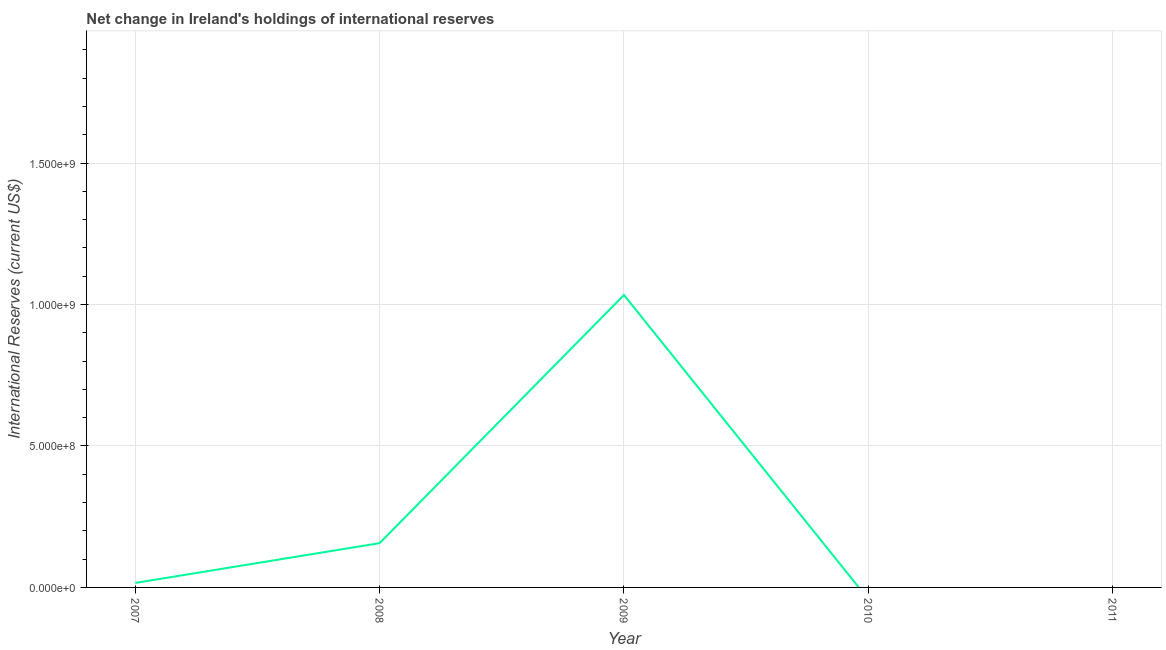What is the reserves and related items in 2011?
Make the answer very short. 0. Across all years, what is the maximum reserves and related items?
Keep it short and to the point. 1.03e+09. What is the sum of the reserves and related items?
Your answer should be very brief. 1.21e+09. What is the difference between the reserves and related items in 2008 and 2009?
Offer a very short reply. -8.77e+08. What is the average reserves and related items per year?
Your response must be concise. 2.41e+08. What is the median reserves and related items?
Provide a succinct answer. 1.60e+07. What is the difference between the highest and the second highest reserves and related items?
Offer a terse response. 8.77e+08. Is the sum of the reserves and related items in 2008 and 2009 greater than the maximum reserves and related items across all years?
Keep it short and to the point. Yes. What is the difference between the highest and the lowest reserves and related items?
Your response must be concise. 1.03e+09. Does the reserves and related items monotonically increase over the years?
Provide a short and direct response. No. How many years are there in the graph?
Ensure brevity in your answer.  5. What is the difference between two consecutive major ticks on the Y-axis?
Provide a succinct answer. 5.00e+08. Does the graph contain any zero values?
Your response must be concise. Yes. What is the title of the graph?
Offer a very short reply. Net change in Ireland's holdings of international reserves. What is the label or title of the X-axis?
Give a very brief answer. Year. What is the label or title of the Y-axis?
Keep it short and to the point. International Reserves (current US$). What is the International Reserves (current US$) in 2007?
Offer a terse response. 1.60e+07. What is the International Reserves (current US$) in 2008?
Provide a short and direct response. 1.57e+08. What is the International Reserves (current US$) of 2009?
Provide a succinct answer. 1.03e+09. What is the difference between the International Reserves (current US$) in 2007 and 2008?
Ensure brevity in your answer.  -1.41e+08. What is the difference between the International Reserves (current US$) in 2007 and 2009?
Ensure brevity in your answer.  -1.02e+09. What is the difference between the International Reserves (current US$) in 2008 and 2009?
Provide a short and direct response. -8.77e+08. What is the ratio of the International Reserves (current US$) in 2007 to that in 2008?
Keep it short and to the point. 0.1. What is the ratio of the International Reserves (current US$) in 2007 to that in 2009?
Ensure brevity in your answer.  0.01. What is the ratio of the International Reserves (current US$) in 2008 to that in 2009?
Keep it short and to the point. 0.15. 